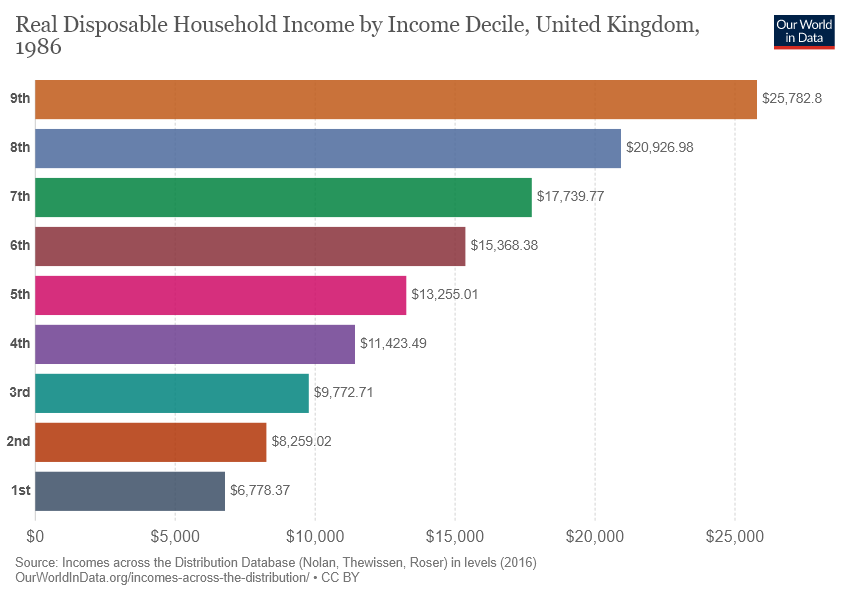Indicate a few pertinent items in this graphic. The smallest two bars combined are not greater than the value of the third largest bar. There are nine colors in the graph. 